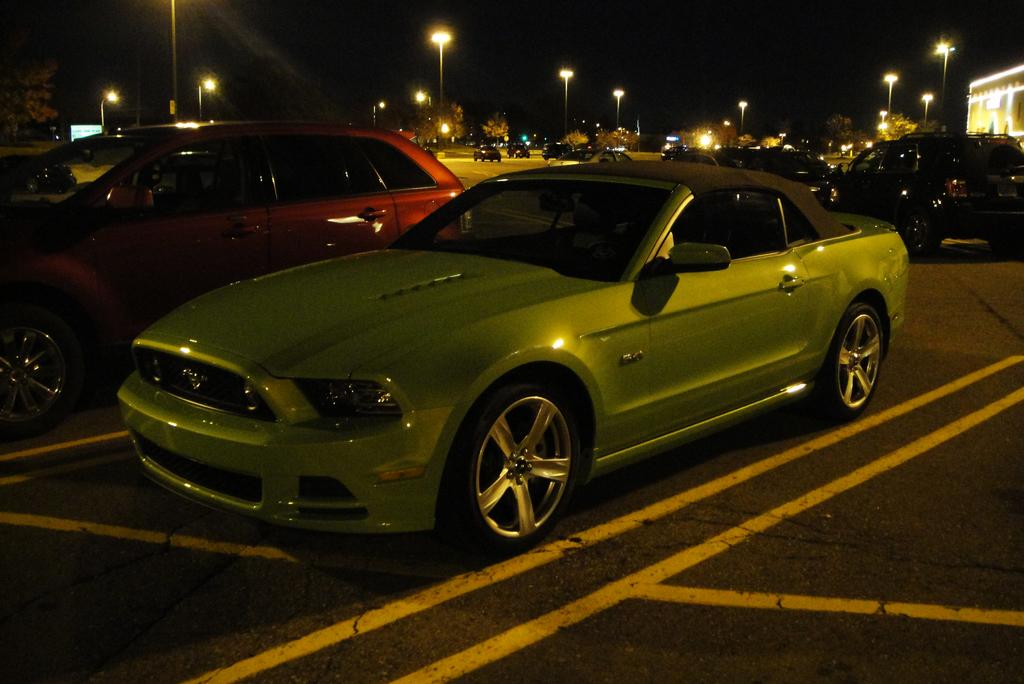What types of objects are present in the image? There are vehicles, light poles, trees, and a building in the image. Can you describe the vehicles in the image? The vehicles in the image are not specified, but they are present. What is located on the right side of the image? There is a building on the right side of the image. What else can be seen in the image besides the vehicles and building? There are light poles and trees in the image. Where is the toothbrush located in the image? There is no toothbrush present in the image. What type of coal is being used to power the vehicles in the image? There is no coal or indication of power source for the vehicles in the image. 